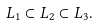<formula> <loc_0><loc_0><loc_500><loc_500>L _ { 1 } \subset L _ { 2 } \subset L _ { 3 } .</formula> 